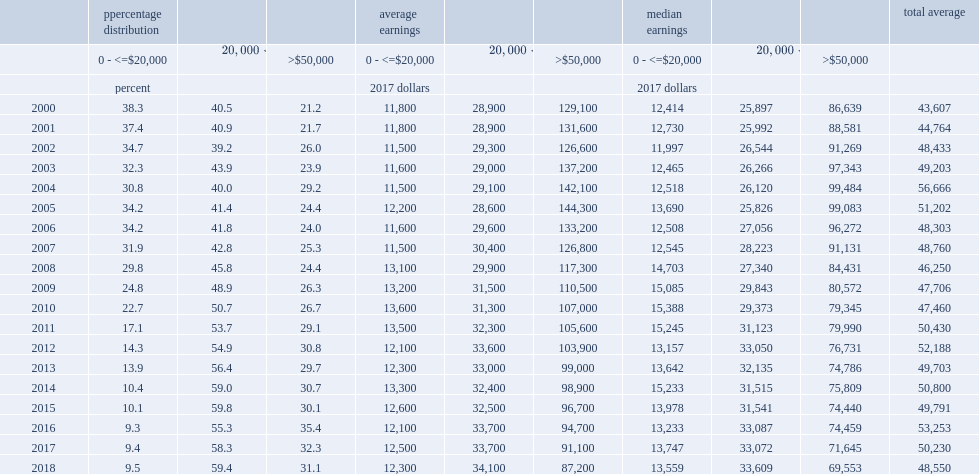What was the share with low pre-immigration canadian earnings (under $20,000 annually) in 2000? 38.3. What was the share with low pre-immigration canadian earnings (under $20,000 annually) in 2018? 9.5. Over the period, what was the proportion of economic principal applicants who had middle-level earnings ($20,000 to $50,000) in 2000? 40.5. Over the period, what was the proportion of economic principal applicants who had middle-level earnings ($20,000 to $50,000) in 2018? 59.4. 